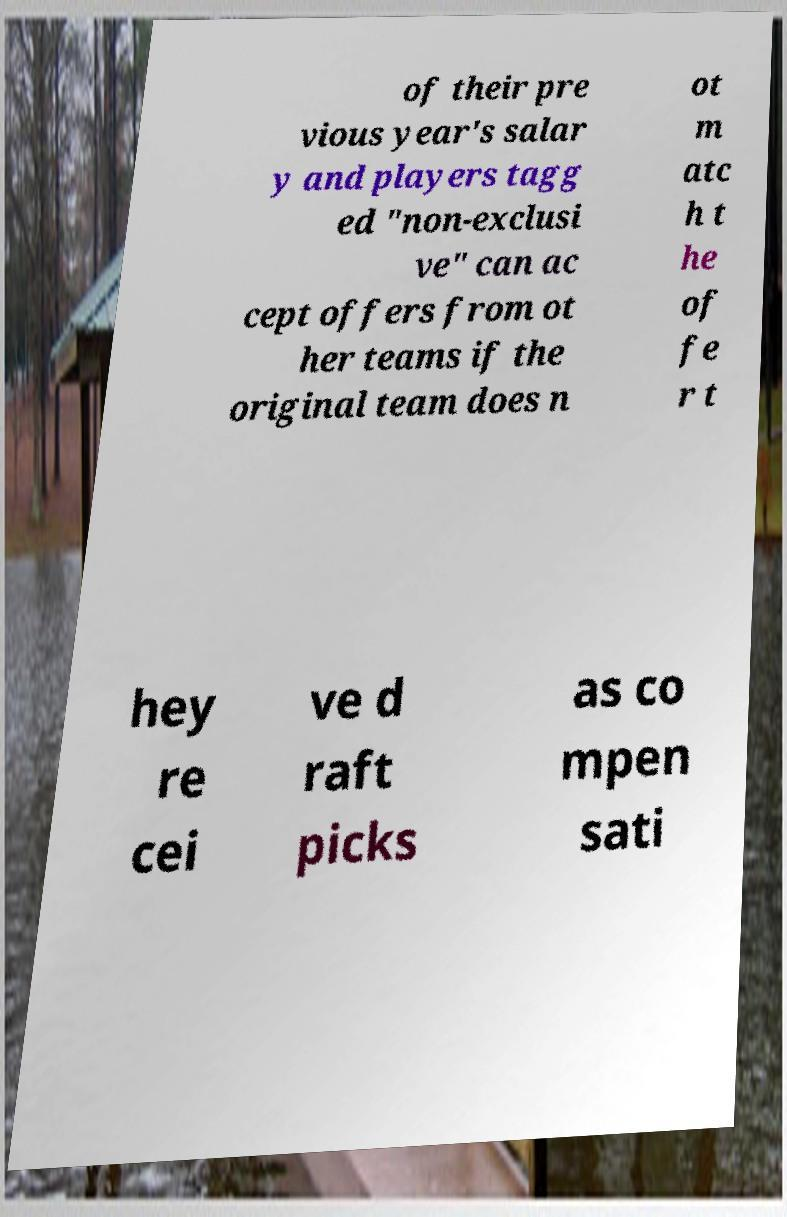Can you accurately transcribe the text from the provided image for me? of their pre vious year's salar y and players tagg ed "non-exclusi ve" can ac cept offers from ot her teams if the original team does n ot m atc h t he of fe r t hey re cei ve d raft picks as co mpen sati 